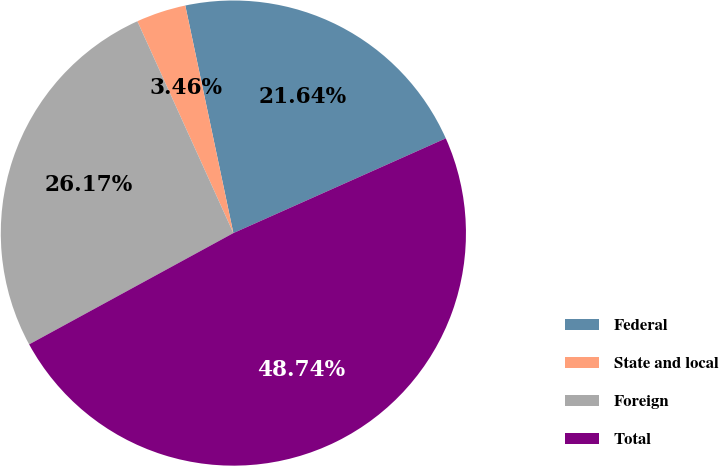<chart> <loc_0><loc_0><loc_500><loc_500><pie_chart><fcel>Federal<fcel>State and local<fcel>Foreign<fcel>Total<nl><fcel>21.64%<fcel>3.46%<fcel>26.17%<fcel>48.74%<nl></chart> 